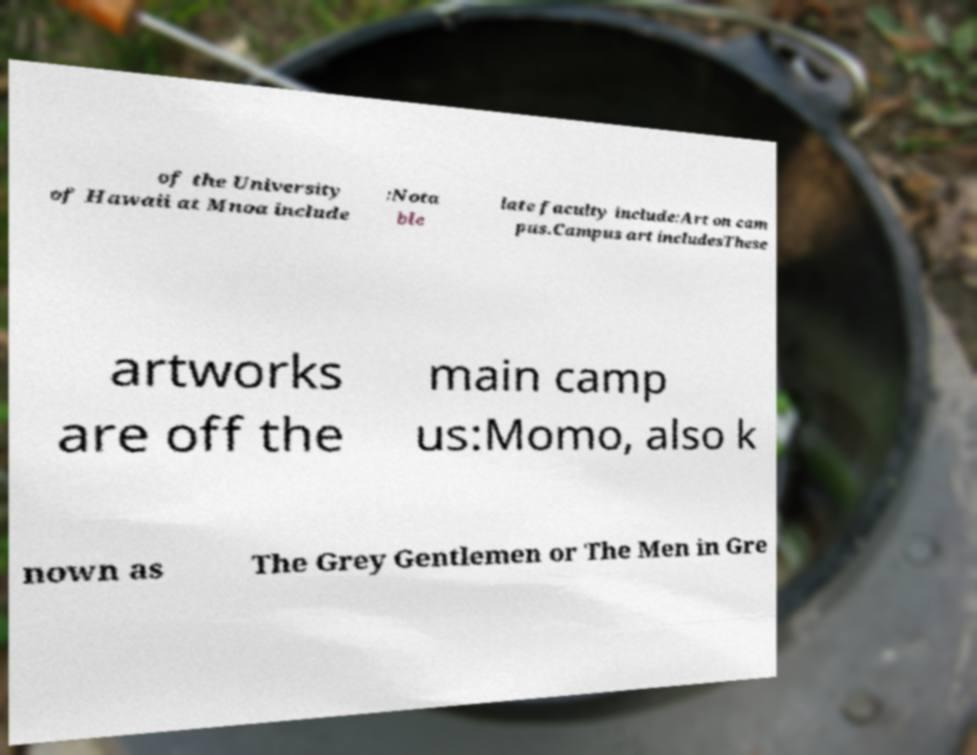Can you read and provide the text displayed in the image?This photo seems to have some interesting text. Can you extract and type it out for me? of the University of Hawaii at Mnoa include :Nota ble late faculty include:Art on cam pus.Campus art includesThese artworks are off the main camp us:Momo, also k nown as The Grey Gentlemen or The Men in Gre 